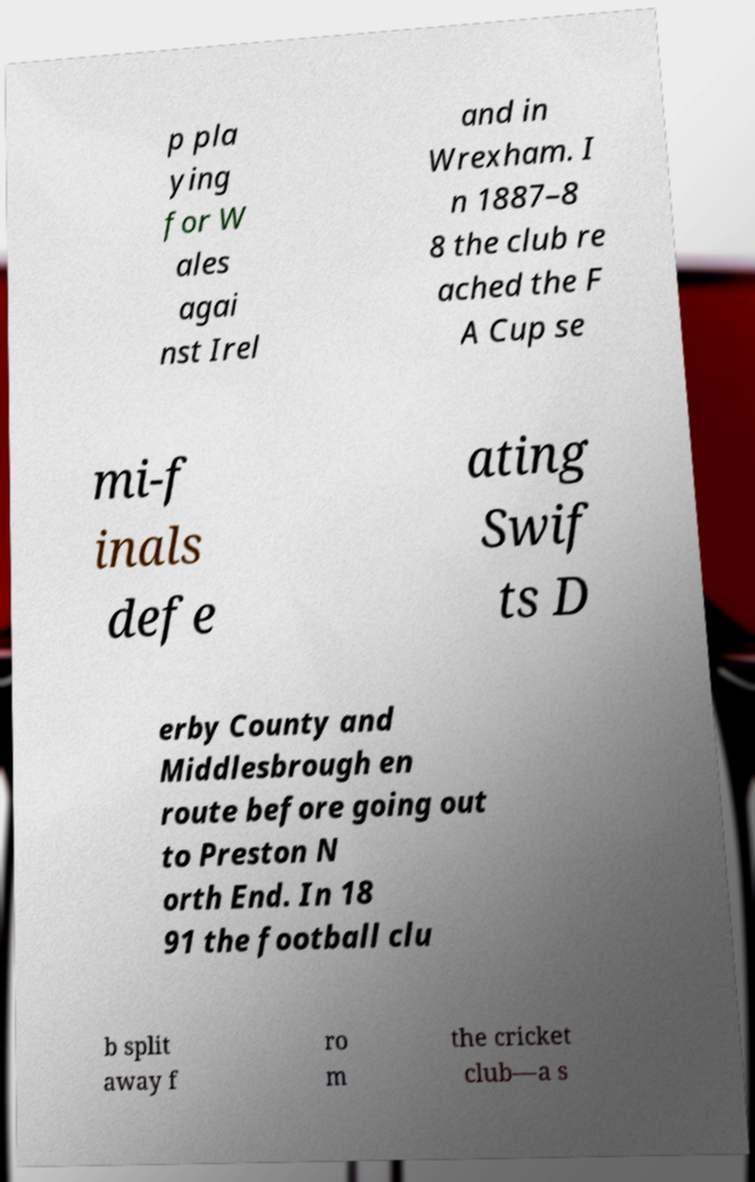Please identify and transcribe the text found in this image. p pla ying for W ales agai nst Irel and in Wrexham. I n 1887–8 8 the club re ached the F A Cup se mi-f inals defe ating Swif ts D erby County and Middlesbrough en route before going out to Preston N orth End. In 18 91 the football clu b split away f ro m the cricket club—a s 